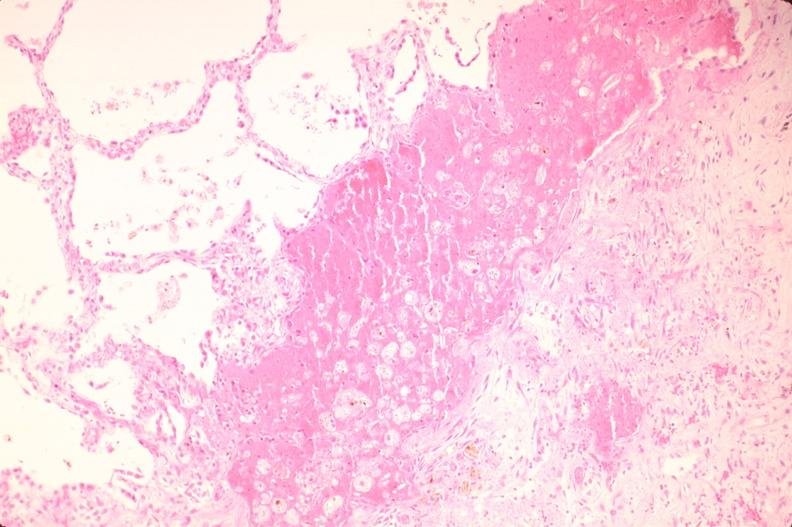what does this image show?
Answer the question using a single word or phrase. Lung 